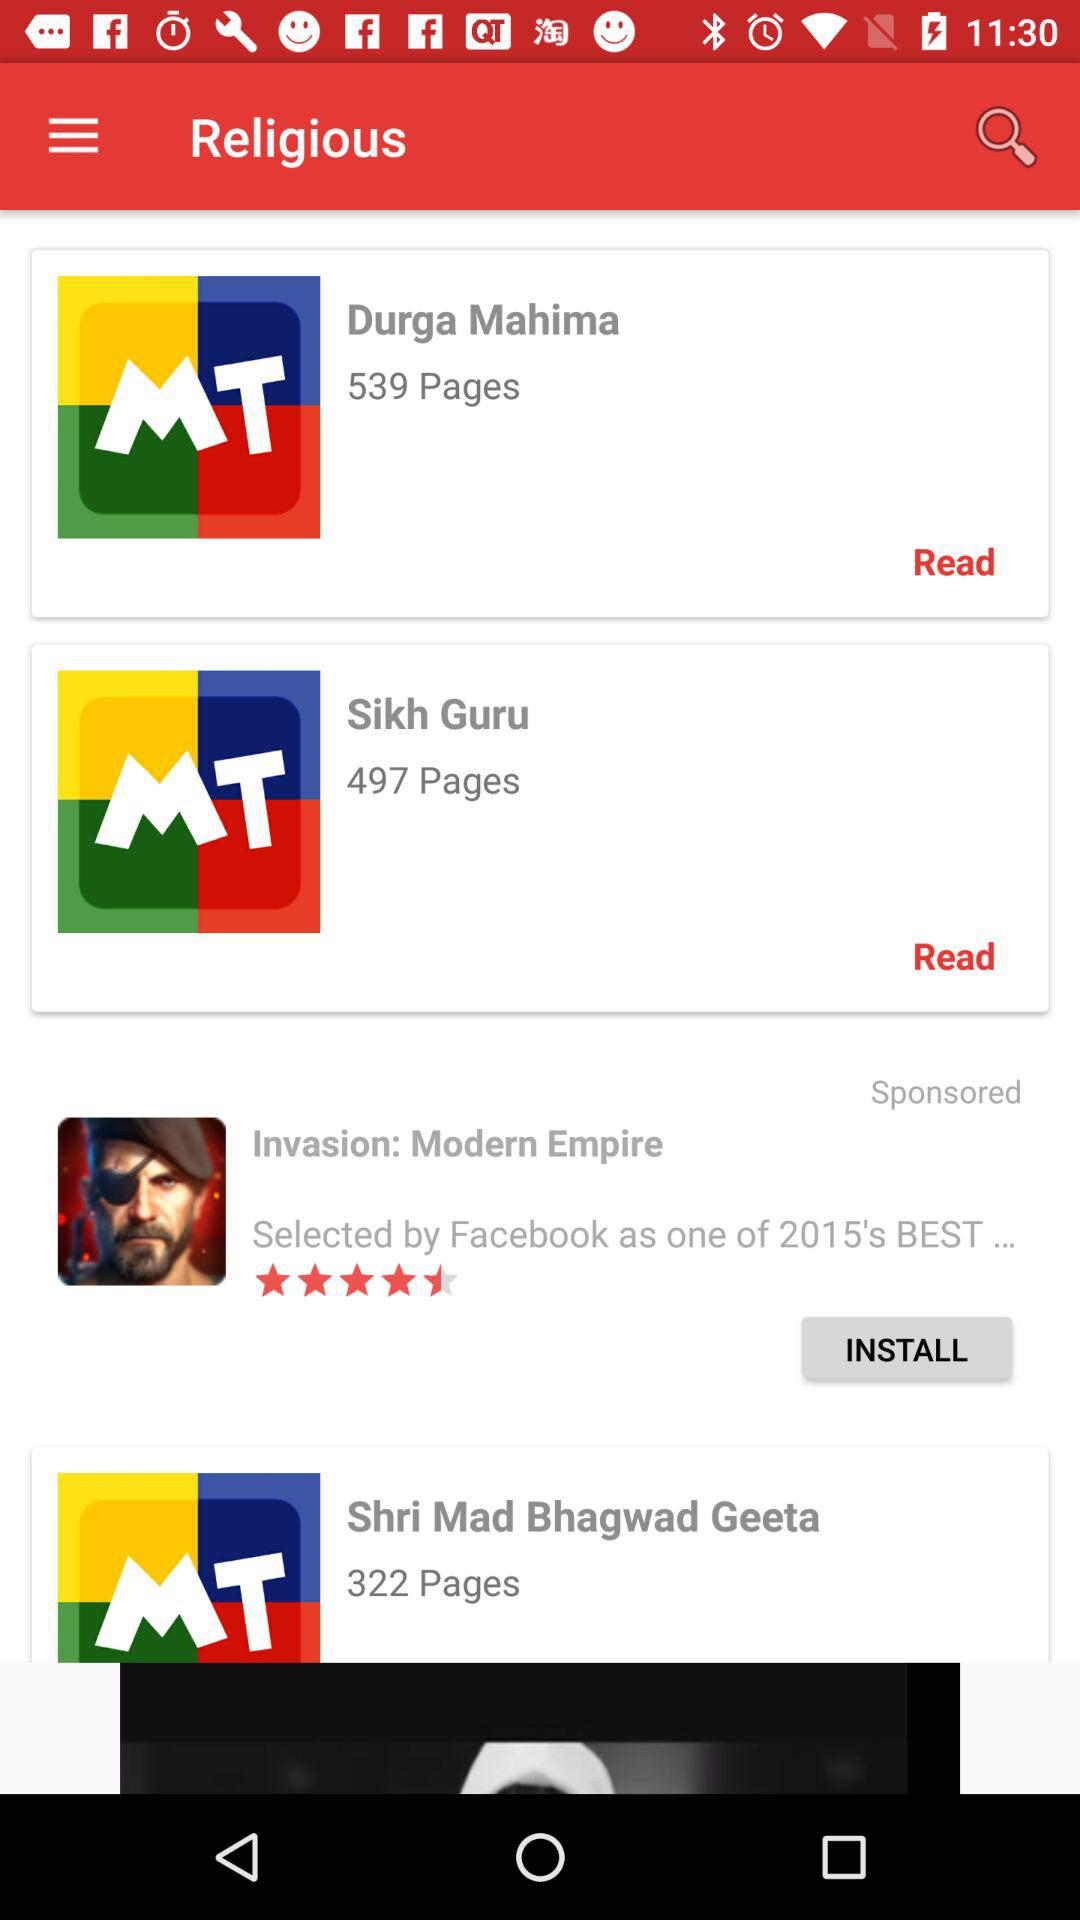How many pages are there in "Durga Mahima"? There are 539 pages in "Durga Mahima". 